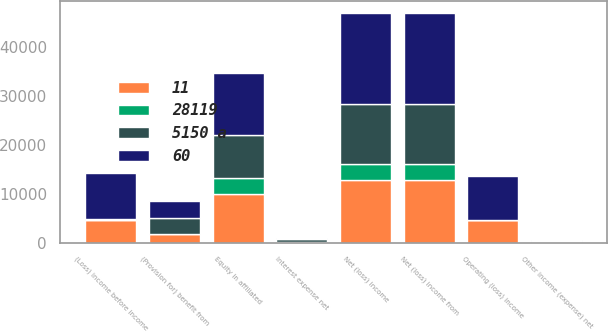Convert chart to OTSL. <chart><loc_0><loc_0><loc_500><loc_500><stacked_bar_chart><ecel><fcel>Operating (loss) income<fcel>Interest expense net<fcel>Other income (expense) net<fcel>(Loss) income before income<fcel>(Provision for) benefit from<fcel>Equity in affiliated<fcel>Net (loss) income from<fcel>Net (loss) income<nl><fcel>5150 a<fcel>60<fcel>489<fcel>225<fcel>324<fcel>3227<fcel>8685<fcel>12236<fcel>12236<nl><fcel>11<fcel>4537<fcel>8<fcel>1<fcel>4544<fcel>1718<fcel>9976<fcel>12802<fcel>12802<nl><fcel>60<fcel>8926<fcel>272<fcel>86<fcel>9284<fcel>3469<fcel>12838<fcel>18653<fcel>18562<nl><fcel>28119<fcel>11<fcel>152<fcel>139<fcel>24<fcel>9<fcel>3227<fcel>3227<fcel>3227<nl></chart> 